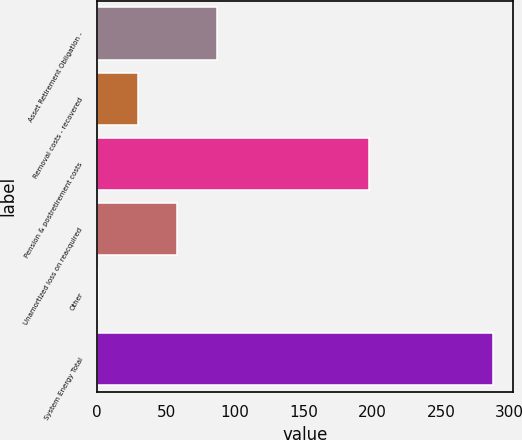<chart> <loc_0><loc_0><loc_500><loc_500><bar_chart><fcel>Asset Retirement Obligation -<fcel>Removal costs - recovered<fcel>Pension & postretirement costs<fcel>Unamortized loss on reacquired<fcel>Other<fcel>System Energy Total<nl><fcel>86.76<fcel>29.32<fcel>197.6<fcel>58.04<fcel>0.6<fcel>287.8<nl></chart> 